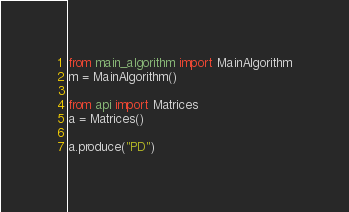Convert code to text. <code><loc_0><loc_0><loc_500><loc_500><_Python_>from main_algorithm import MainAlgorithm
m = MainAlgorithm()

from api import Matrices
a = Matrices()

a.produce("PD")
</code> 